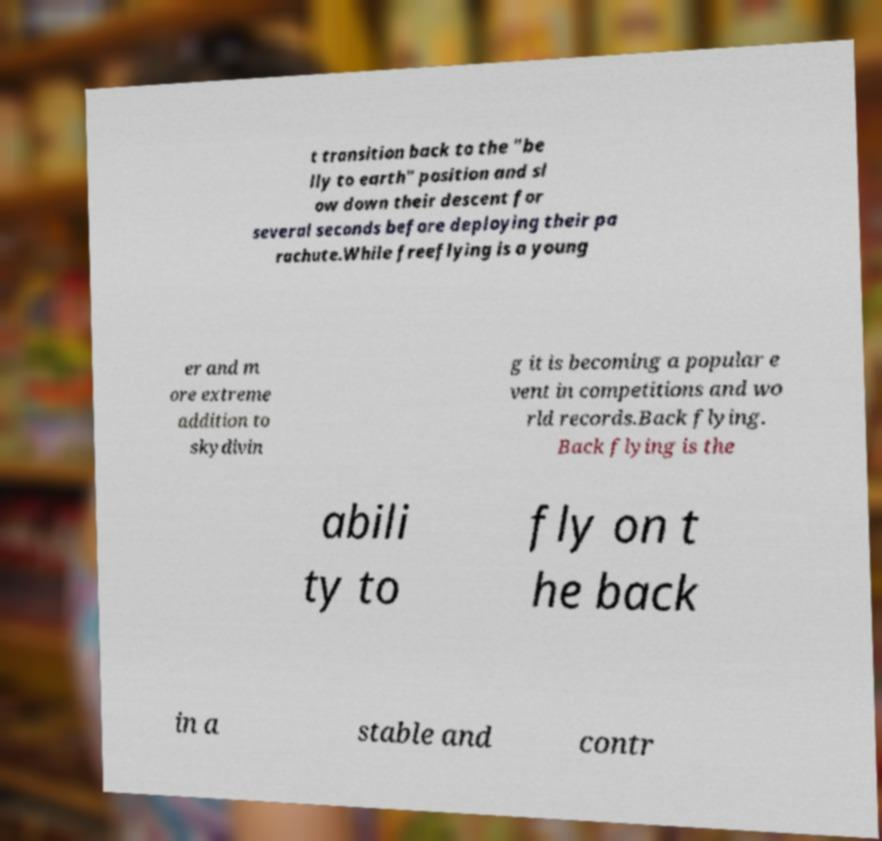Can you read and provide the text displayed in the image?This photo seems to have some interesting text. Can you extract and type it out for me? t transition back to the "be lly to earth" position and sl ow down their descent for several seconds before deploying their pa rachute.While freeflying is a young er and m ore extreme addition to skydivin g it is becoming a popular e vent in competitions and wo rld records.Back flying. Back flying is the abili ty to fly on t he back in a stable and contr 